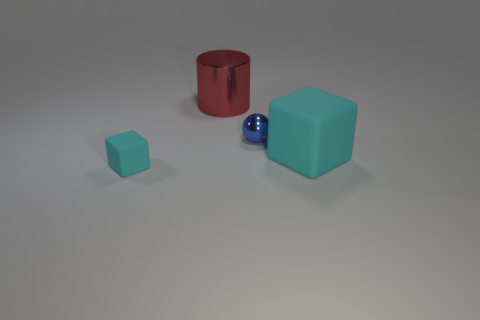Subtract 1 cubes. How many cubes are left? 1 Add 4 blue rubber blocks. How many objects exist? 8 Subtract all cylinders. How many objects are left? 3 Subtract all purple spheres. Subtract all gray cylinders. How many spheres are left? 1 Add 2 small cyan rubber cubes. How many small cyan rubber cubes are left? 3 Add 1 balls. How many balls exist? 2 Subtract 0 gray spheres. How many objects are left? 4 Subtract all small cubes. Subtract all metallic objects. How many objects are left? 1 